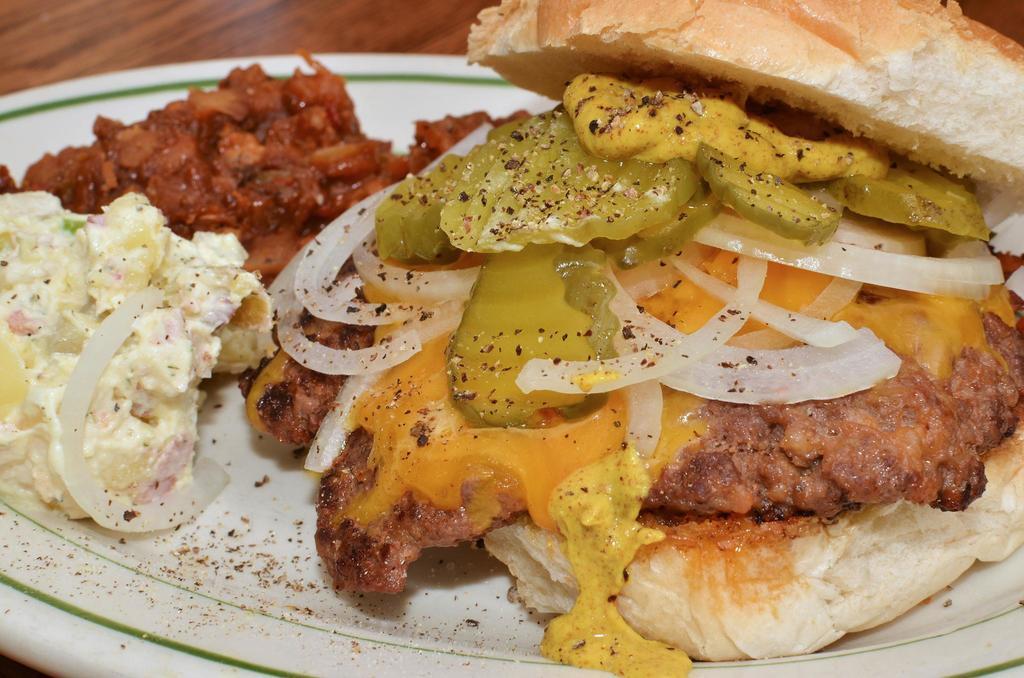Describe this image in one or two sentences. In this image we can see food placed in a plate on the surface. 